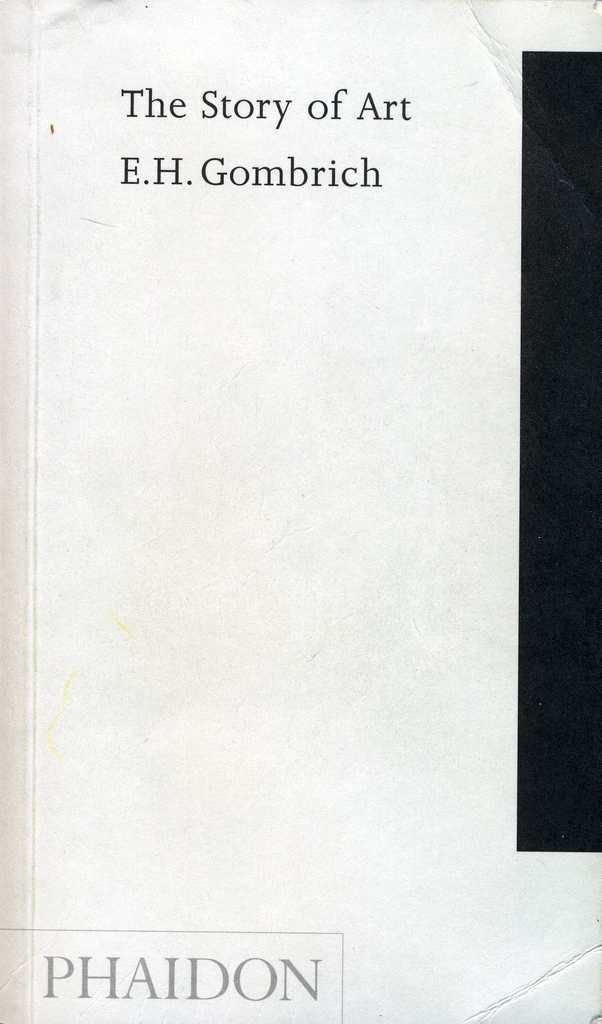<image>
Summarize the visual content of the image. A white page with "The Story of Art" and Phaidon in the lower left corner. 